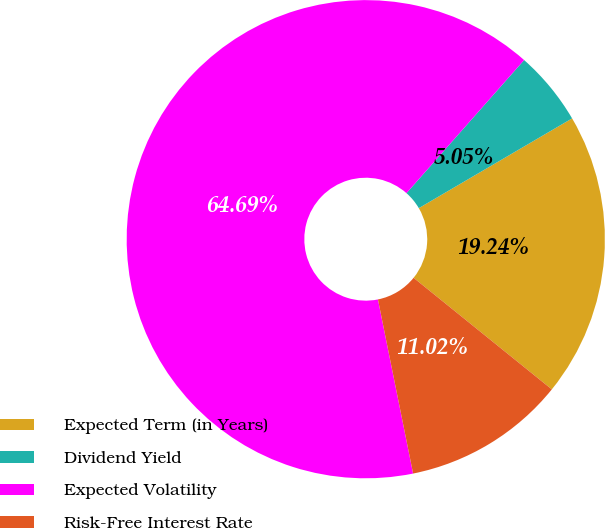Convert chart to OTSL. <chart><loc_0><loc_0><loc_500><loc_500><pie_chart><fcel>Expected Term (in Years)<fcel>Dividend Yield<fcel>Expected Volatility<fcel>Risk-Free Interest Rate<nl><fcel>19.24%<fcel>5.05%<fcel>64.7%<fcel>11.02%<nl></chart> 